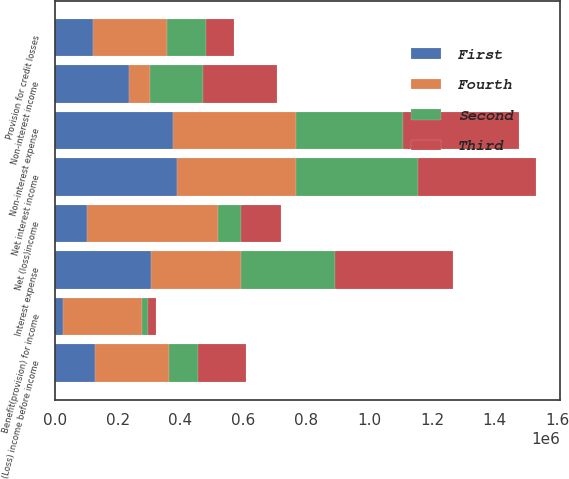Convert chart. <chart><loc_0><loc_0><loc_500><loc_500><stacked_bar_chart><ecel><fcel>Interest expense<fcel>Net interest income<fcel>Provision for credit losses<fcel>Non-interest income<fcel>Non-interest expense<fcel>(Loss) income before income<fcel>Benefit(provision) for income<fcel>Net (loss)income<nl><fcel>Fourth<fcel>286143<fcel>376365<fcel>236091<fcel>67099<fcel>390094<fcel>236091<fcel>251949<fcel>417289<nl><fcel>Second<fcel>297092<fcel>388636<fcel>125392<fcel>167857<fcel>338996<fcel>92105<fcel>17042<fcel>75063<nl><fcel>First<fcel>306809<fcel>389866<fcel>120813<fcel>236430<fcel>377803<fcel>127680<fcel>26328<fcel>101352<nl><fcel>Third<fcel>376587<fcel>376824<fcel>88650<fcel>235752<fcel>370481<fcel>153445<fcel>26377<fcel>127068<nl></chart> 